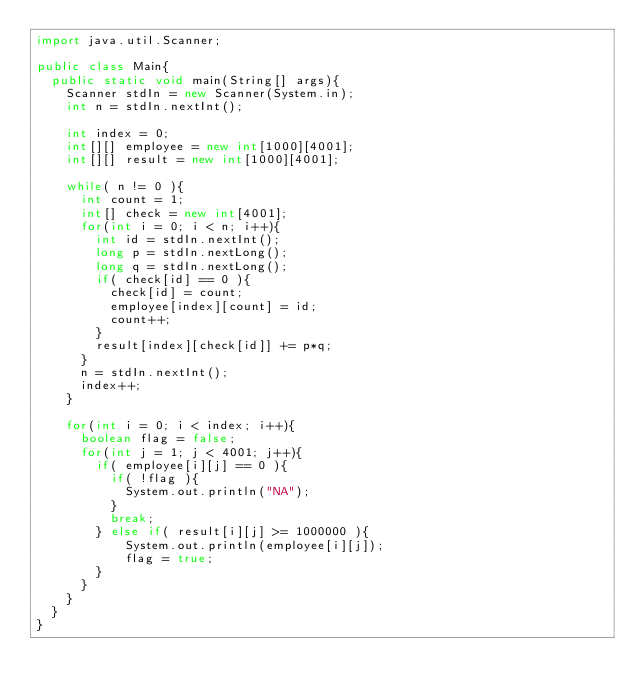<code> <loc_0><loc_0><loc_500><loc_500><_Java_>import java.util.Scanner;

public class Main{
	public static void main(String[] args){
		Scanner stdIn = new Scanner(System.in);
		int n = stdIn.nextInt();
		
		int index = 0;
		int[][] employee = new int[1000][4001];
		int[][] result = new int[1000][4001];
		
		while( n != 0 ){
			int count = 1;
			int[] check = new int[4001];
			for(int i = 0; i < n; i++){
				int id = stdIn.nextInt();
				long p = stdIn.nextLong();
				long q = stdIn.nextLong();
				if( check[id] == 0 ){
					check[id] = count;
					employee[index][count] = id;
					count++;
				} 
				result[index][check[id]] += p*q;
			}
			n = stdIn.nextInt();
			index++;
		}
		
		for(int i = 0; i < index; i++){
			boolean flag = false;
			for(int j = 1; j < 4001; j++){
				if( employee[i][j] == 0 ){
					if( !flag ){
						System.out.println("NA");
					}
					break;
				} else if( result[i][j] >= 1000000 ){
						System.out.println(employee[i][j]);
						flag = true;
				}
			}
		}
	}
}</code> 